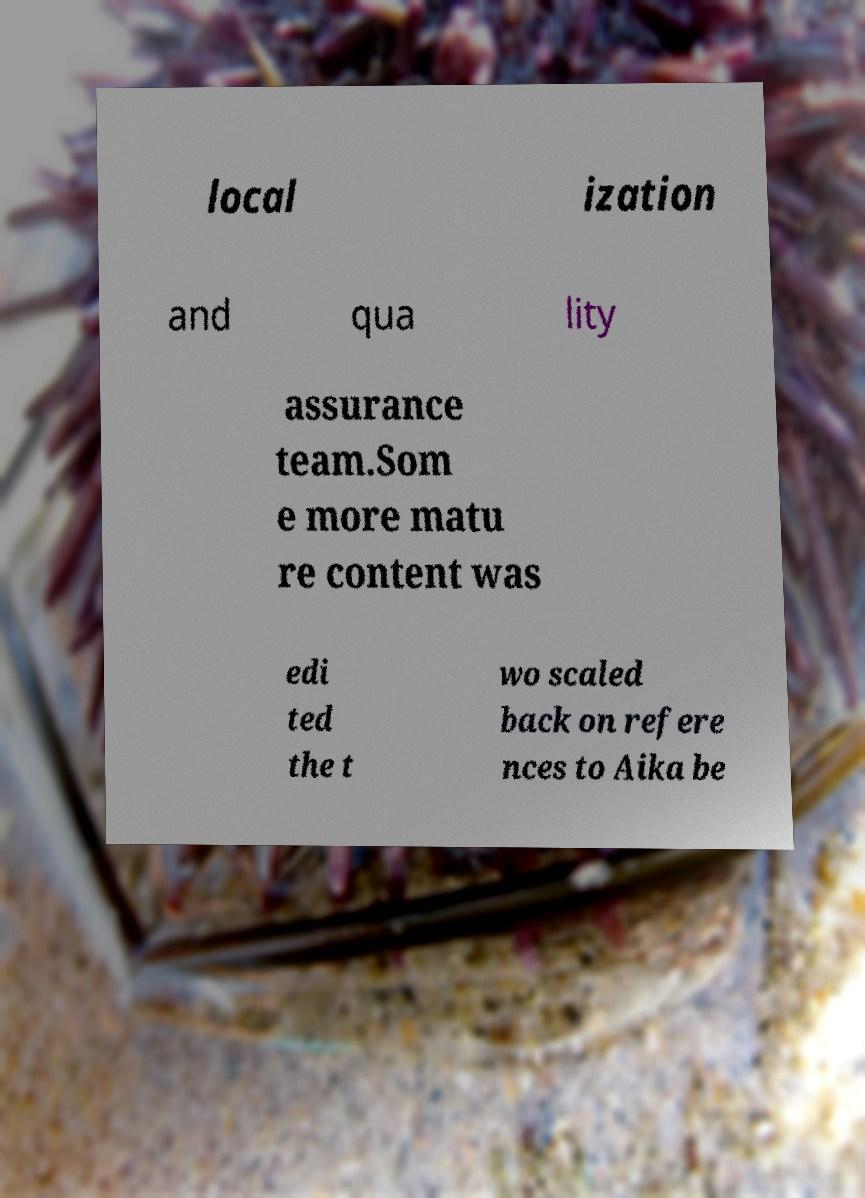What messages or text are displayed in this image? I need them in a readable, typed format. local ization and qua lity assurance team.Som e more matu re content was edi ted the t wo scaled back on refere nces to Aika be 